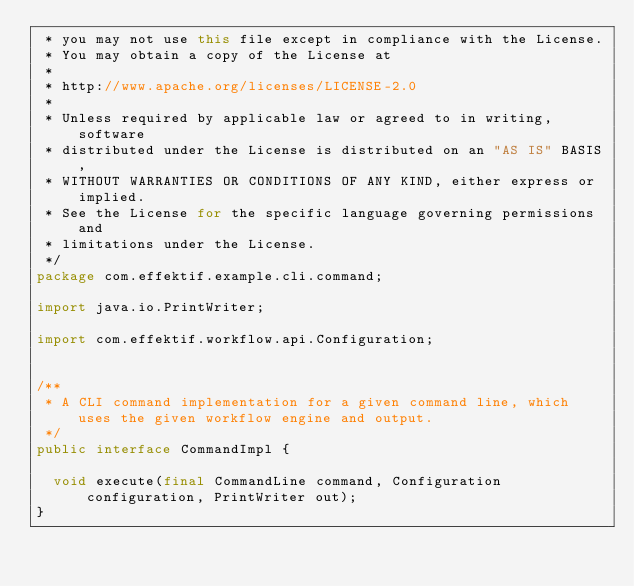Convert code to text. <code><loc_0><loc_0><loc_500><loc_500><_Java_> * you may not use this file except in compliance with the License.
 * You may obtain a copy of the License at
 *
 * http://www.apache.org/licenses/LICENSE-2.0
 *
 * Unless required by applicable law or agreed to in writing, software
 * distributed under the License is distributed on an "AS IS" BASIS,
 * WITHOUT WARRANTIES OR CONDITIONS OF ANY KIND, either express or implied.
 * See the License for the specific language governing permissions and
 * limitations under the License.
 */
package com.effektif.example.cli.command;

import java.io.PrintWriter;

import com.effektif.workflow.api.Configuration;


/**
 * A CLI command implementation for a given command line, which uses the given workflow engine and output.
 */
public interface CommandImpl {

  void execute(final CommandLine command, Configuration configuration, PrintWriter out);
}
</code> 